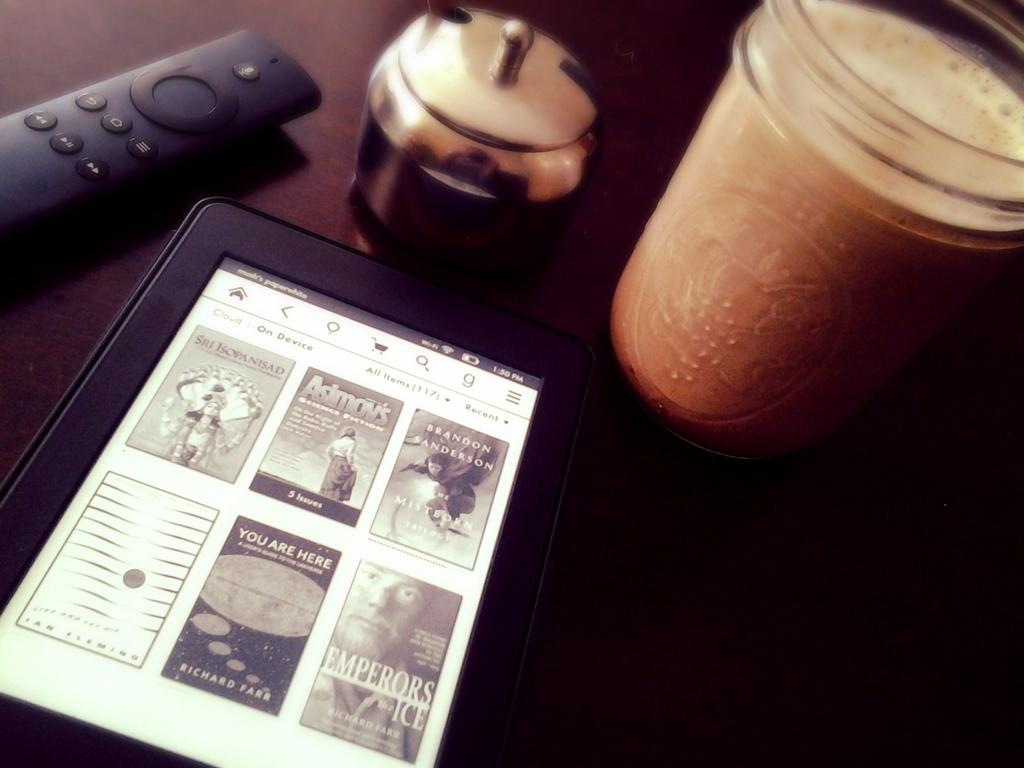<image>
Describe the image concisely. A tablet with books on it, including one called Emperors of the Ice. 